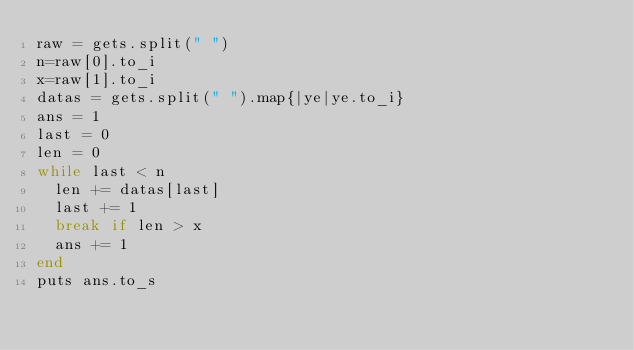Convert code to text. <code><loc_0><loc_0><loc_500><loc_500><_Ruby_>raw = gets.split(" ")
n=raw[0].to_i
x=raw[1].to_i
datas = gets.split(" ").map{|ye|ye.to_i}
ans = 1
last = 0
len = 0
while last < n
  len += datas[last]
  last += 1
  break if len > x
  ans += 1
end
puts ans.to_s</code> 